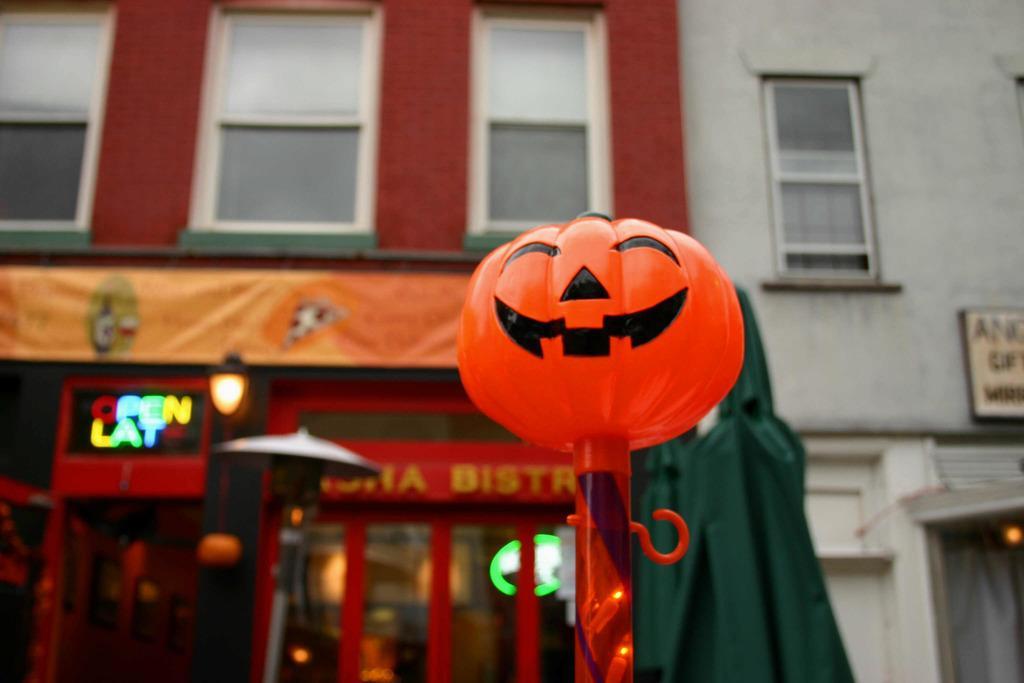Could you give a brief overview of what you see in this image? In the image there is an artificial Halloween pumpkin attached to a pole and behind the pole there is a store and there is a building above the store. 